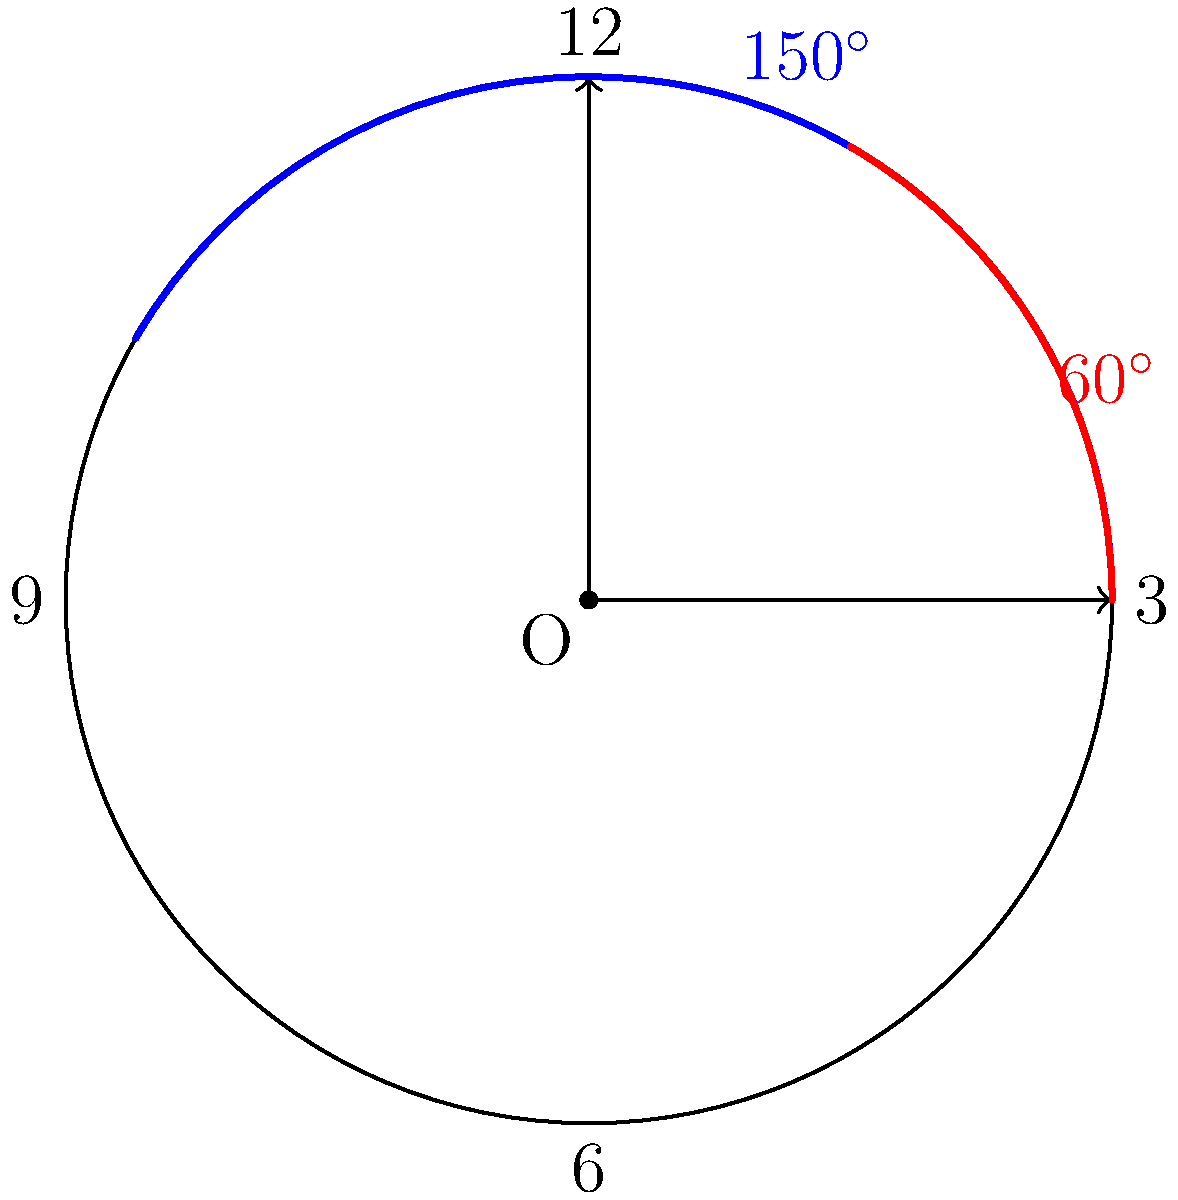In a thrilling scene from a popular Tamil TV show, Jiiva's character is seen racing against time at the iconic Chennai Central clock tower. The hour hand of the clock forms a $150^\circ$ angle with the 12 o'clock position, while the minute hand forms a $60^\circ$ angle. What is the acute angle between the hour and minute hands? Let's solve this step-by-step:

1) First, we need to understand how the clock hands move:
   - The hour hand makes a complete $360^\circ$ rotation in 12 hours, so it moves at a rate of $30^\circ$ per hour.
   - The minute hand makes a complete $360^\circ$ rotation in 1 hour, so it moves at a rate of $6^\circ$ per minute.

2) The hour hand is at $150^\circ$ from 12 o'clock position. This means:
   - Time passed = $150^\circ \div 30^\circ/\text{hour} = 5$ hours

3) The minute hand is at $60^\circ$ from 12 o'clock position. This means:
   - Minutes passed = $60^\circ \div 6^\circ/\text{minute} = 10$ minutes

4) So, the time shown on the clock is 5:10

5) To find the acute angle between the hands, we calculate:
   - Angle of hour hand from 12 o'clock = $150^\circ$
   - Angle of minute hand from 12 o'clock = $60^\circ$
   - Angle between hands = $150^\circ - 60^\circ = 90^\circ$

6) The question asks for the acute angle, and $90^\circ$ is already the smallest positive angle between the hands.

Therefore, the acute angle between the hour and minute hands is $90^\circ$.
Answer: $90^\circ$ 